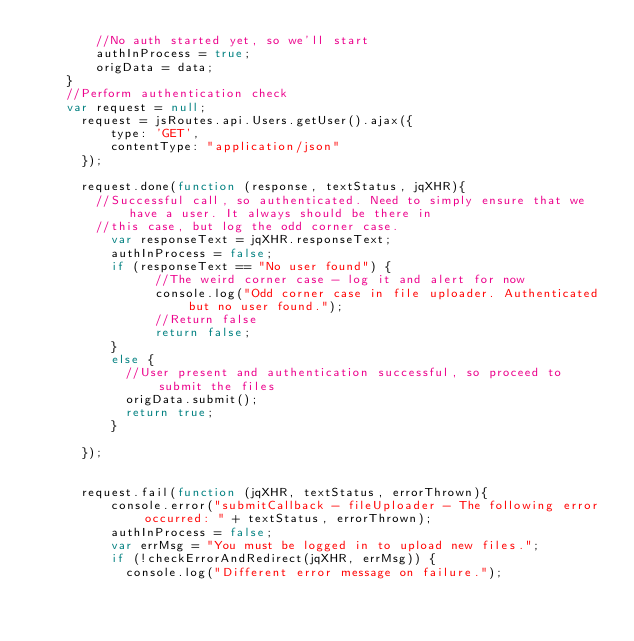Convert code to text. <code><loc_0><loc_0><loc_500><loc_500><_JavaScript_>  		//No auth started yet, so we'll start
  		authInProcess = true;
  		origData = data;
  	}
  	//Perform authentication check
  	var request = null;		                         	                        
      request = jsRoutes.api.Users.getUser().ajax({
          type: 'GET',
          contentType: "application/json"
      });
  	                        	                        
      request.done(function (response, textStatus, jqXHR){	                            
        //Successful call, so authenticated. Need to simply ensure that we have a user. It always should be there in
      	//this case, but log the odd corner case.
          var responseText = jqXHR.responseText;       
          authInProcess = false;
          if (responseText == "No user found") {
	            //The weird corner case - log it and alert for now
	            console.log("Odd corner case in file uploader. Authenticated but no user found.");
	            //Return false
	            return false;
          }
          else {
          	//User present and authentication successful, so proceed to submit the files
          	origData.submit();
          	return true;
          }
                      
      });


      request.fail(function (jqXHR, textStatus, errorThrown){
          console.error("submitCallback - fileUploader - The following error occurred: " + textStatus, errorThrown);
          authInProcess = false;
          var errMsg = "You must be logged in to upload new files.";                                
          if (!checkErrorAndRedirect(jqXHR, errMsg)) {            	
          	console.log("Different error message on failure.");</code> 